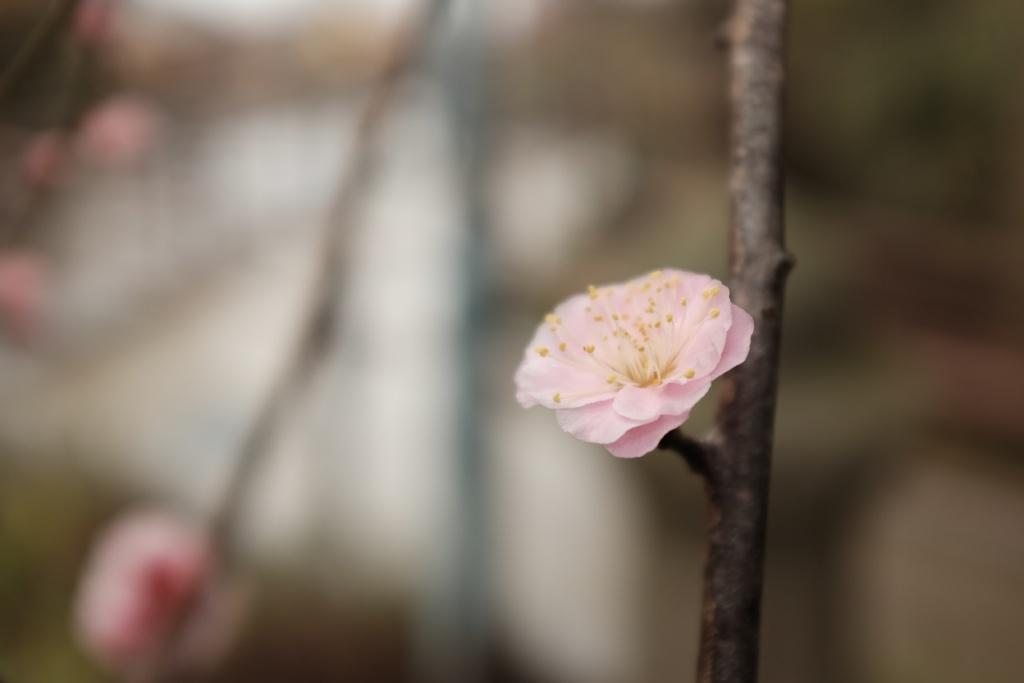What is: What is the main subject of the image? There is a flower on a stem in the image. Can you describe the background of the image? The background of the image is blurred. What type of blade can be seen in the image? There is no blade present in the image; it features a flower on a stem with a blurred background. 